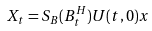Convert formula to latex. <formula><loc_0><loc_0><loc_500><loc_500>X _ { t } = S _ { B } ( B ^ { H } _ { t } ) U ( t , 0 ) x</formula> 